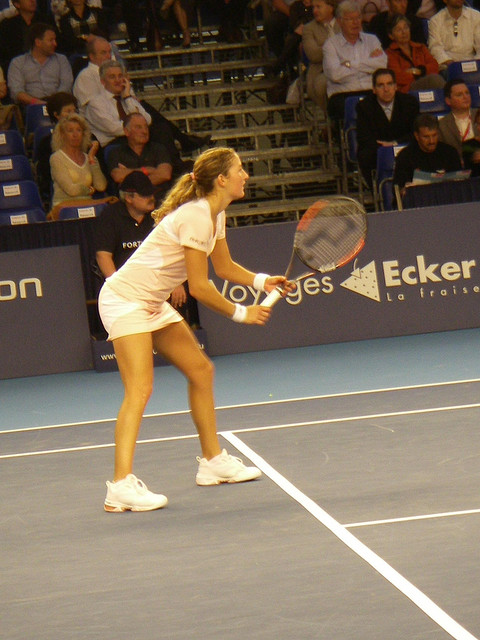Identify and read out the text in this image. joyyges FORT on Ecker Fraise 